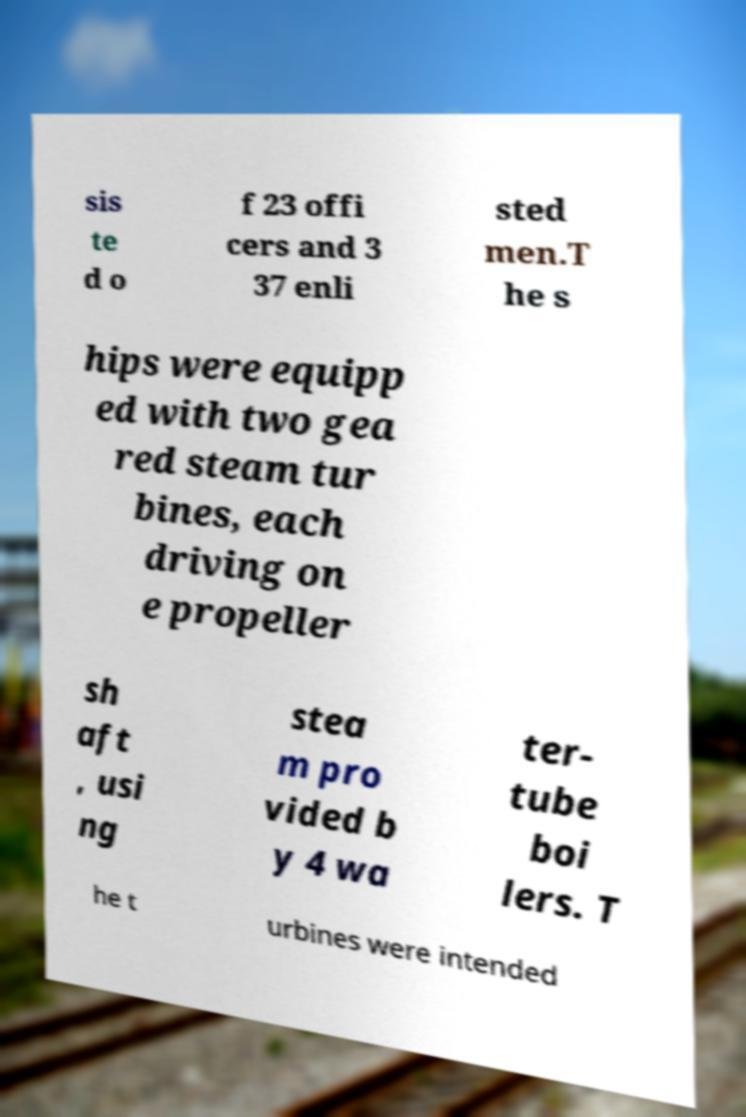Can you read and provide the text displayed in the image?This photo seems to have some interesting text. Can you extract and type it out for me? sis te d o f 23 offi cers and 3 37 enli sted men.T he s hips were equipp ed with two gea red steam tur bines, each driving on e propeller sh aft , usi ng stea m pro vided b y 4 wa ter- tube boi lers. T he t urbines were intended 